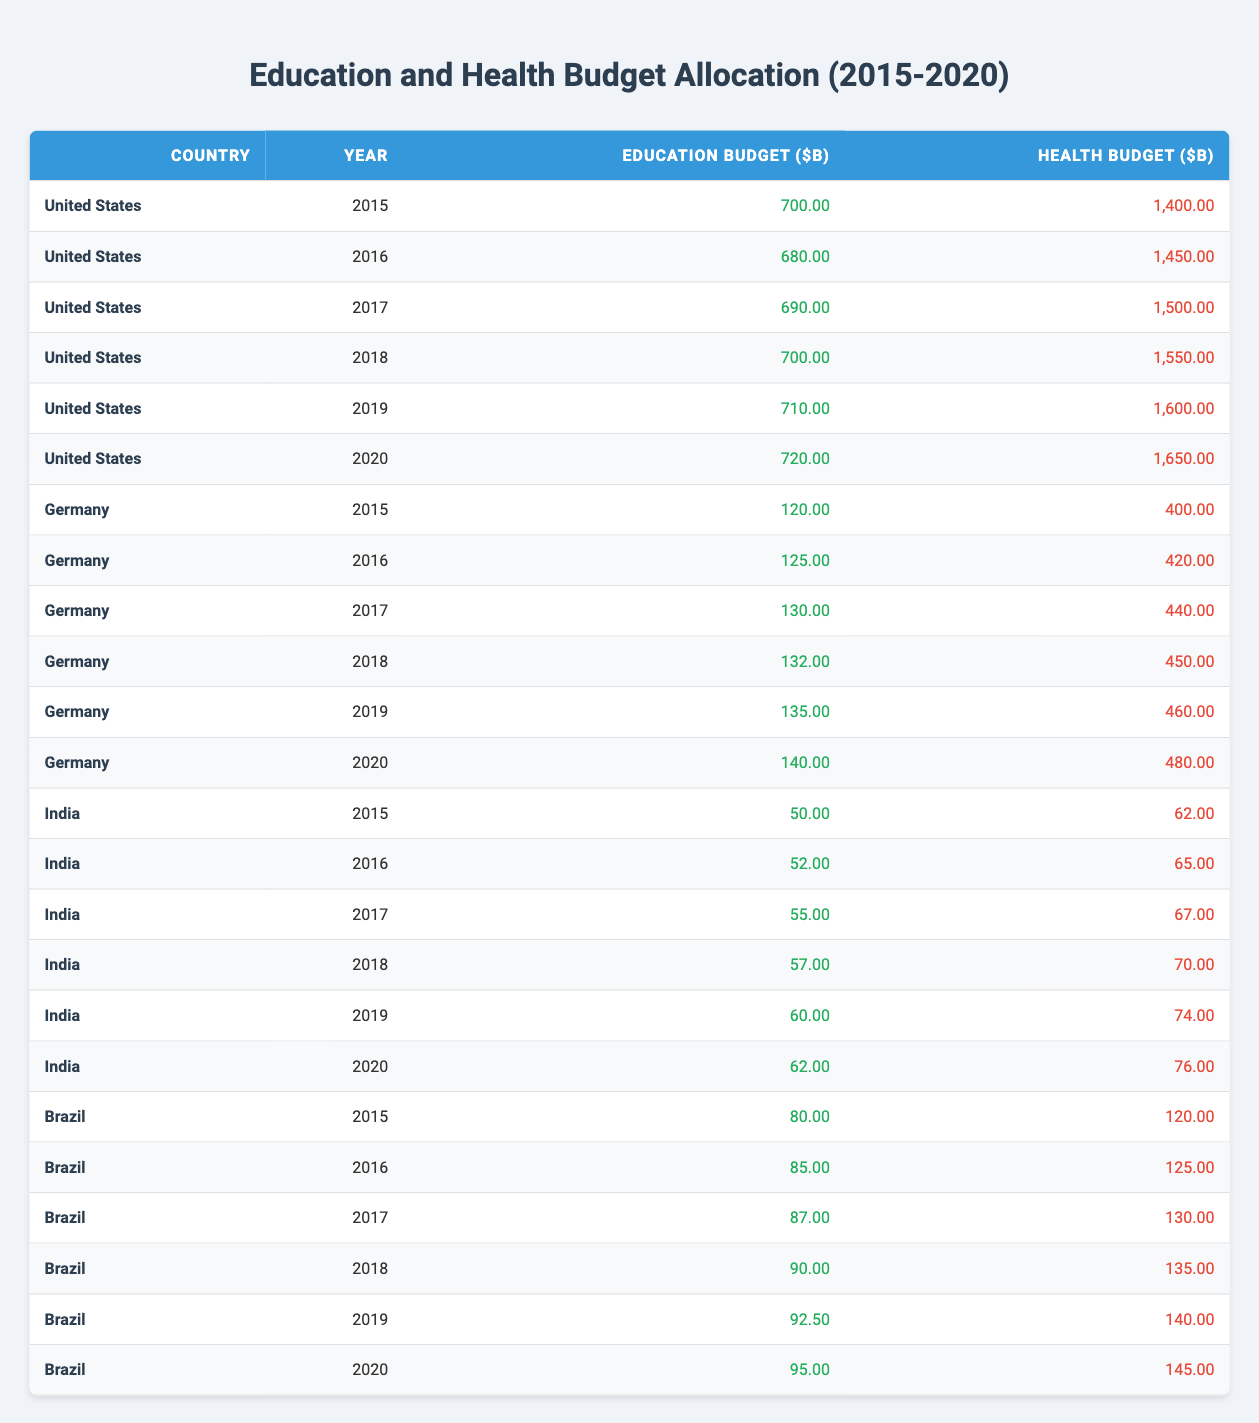What was the health budget of the United States in 2017? From the table, we look at the row for the United States in 2017. The health budget is listed as 1,500.00 billion dollars.
Answer: 1,500.00 billion dollars Which country had the highest education budget in 2020? Reviewing the table for the year 2020, we see that the United States has an education budget of 720.00 billion, Germany has 140.00 billion, India has 62.00 billion, and Brazil has 95.00 billion. Hence, the United States has the highest education budget.
Answer: United States What was the difference between Germany's health budget in 2015 and 2020? In 2015, Germany's health budget was 400.00 billion and in 2020 it was 480.00 billion. To find the difference, we subtract: 480.00 - 400.00 = 80.00 billion.
Answer: 80.00 billion Did Brazil's education budget increase every year from 2015 to 2020? Looking at the values in the table for Brazil, we see that the education budgets were: 80.00 in 2015, 85.00 in 2016, 87.00 in 2017, 90.00 in 2018, 92.50 in 2019, and 95.00 in 2020. Since all values consistently increased, the answer is yes.
Answer: Yes What is the average health budget across all countries in 2019? In 2019, the health budgets are: United States 1,600.00, Germany 460.00, India 74.00, and Brazil 140.00. First, sum these values: 1,600.00 + 460.00 + 74.00 + 140.00 = 2,274.00. Then, divide by the number of countries (4). The average is 2,274.00 / 4 = 568.50 billion.
Answer: 568.50 billion 